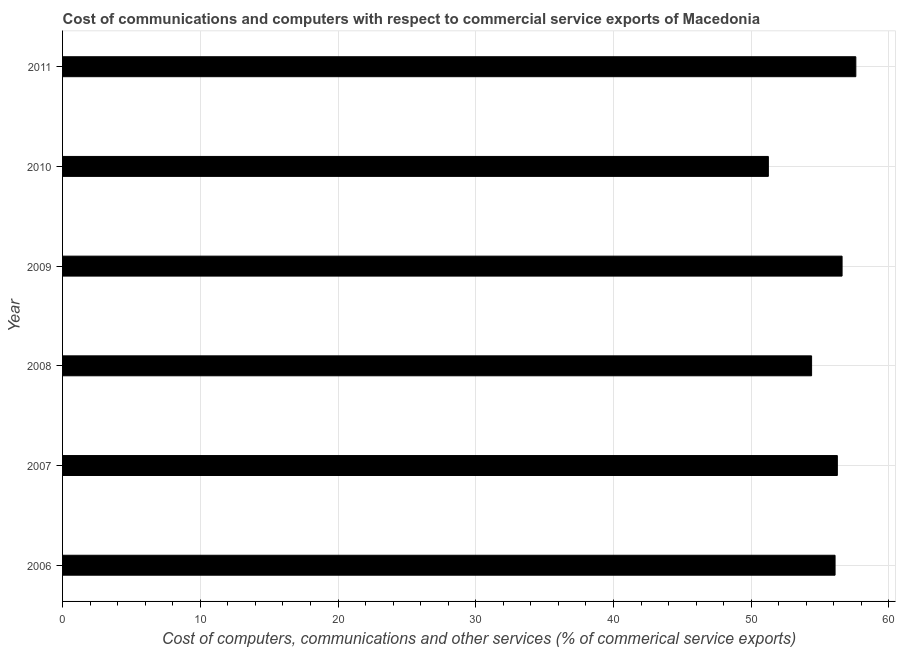What is the title of the graph?
Provide a short and direct response. Cost of communications and computers with respect to commercial service exports of Macedonia. What is the label or title of the X-axis?
Your answer should be compact. Cost of computers, communications and other services (% of commerical service exports). What is the label or title of the Y-axis?
Offer a very short reply. Year. What is the  computer and other services in 2010?
Provide a short and direct response. 51.24. Across all years, what is the maximum cost of communications?
Keep it short and to the point. 57.59. Across all years, what is the minimum cost of communications?
Offer a terse response. 51.24. In which year was the cost of communications minimum?
Offer a terse response. 2010. What is the sum of the cost of communications?
Keep it short and to the point. 332.15. What is the difference between the cost of communications in 2010 and 2011?
Provide a succinct answer. -6.35. What is the average cost of communications per year?
Make the answer very short. 55.36. What is the median cost of communications?
Your response must be concise. 56.17. Do a majority of the years between 2009 and 2006 (inclusive) have  computer and other services greater than 46 %?
Offer a very short reply. Yes. Is the difference between the  computer and other services in 2007 and 2011 greater than the difference between any two years?
Your response must be concise. No. Is the sum of the  computer and other services in 2008 and 2009 greater than the maximum  computer and other services across all years?
Your answer should be very brief. Yes. What is the difference between the highest and the lowest cost of communications?
Keep it short and to the point. 6.35. In how many years, is the cost of communications greater than the average cost of communications taken over all years?
Make the answer very short. 4. How many bars are there?
Your response must be concise. 6. Are all the bars in the graph horizontal?
Keep it short and to the point. Yes. How many years are there in the graph?
Make the answer very short. 6. What is the difference between two consecutive major ticks on the X-axis?
Your answer should be very brief. 10. Are the values on the major ticks of X-axis written in scientific E-notation?
Make the answer very short. No. What is the Cost of computers, communications and other services (% of commerical service exports) of 2006?
Offer a very short reply. 56.09. What is the Cost of computers, communications and other services (% of commerical service exports) in 2007?
Ensure brevity in your answer.  56.25. What is the Cost of computers, communications and other services (% of commerical service exports) in 2008?
Give a very brief answer. 54.38. What is the Cost of computers, communications and other services (% of commerical service exports) in 2009?
Offer a terse response. 56.6. What is the Cost of computers, communications and other services (% of commerical service exports) of 2010?
Give a very brief answer. 51.24. What is the Cost of computers, communications and other services (% of commerical service exports) of 2011?
Offer a terse response. 57.59. What is the difference between the Cost of computers, communications and other services (% of commerical service exports) in 2006 and 2007?
Provide a succinct answer. -0.17. What is the difference between the Cost of computers, communications and other services (% of commerical service exports) in 2006 and 2008?
Offer a terse response. 1.7. What is the difference between the Cost of computers, communications and other services (% of commerical service exports) in 2006 and 2009?
Keep it short and to the point. -0.51. What is the difference between the Cost of computers, communications and other services (% of commerical service exports) in 2006 and 2010?
Provide a short and direct response. 4.84. What is the difference between the Cost of computers, communications and other services (% of commerical service exports) in 2006 and 2011?
Keep it short and to the point. -1.51. What is the difference between the Cost of computers, communications and other services (% of commerical service exports) in 2007 and 2008?
Your answer should be compact. 1.87. What is the difference between the Cost of computers, communications and other services (% of commerical service exports) in 2007 and 2009?
Ensure brevity in your answer.  -0.34. What is the difference between the Cost of computers, communications and other services (% of commerical service exports) in 2007 and 2010?
Provide a short and direct response. 5.01. What is the difference between the Cost of computers, communications and other services (% of commerical service exports) in 2007 and 2011?
Your answer should be very brief. -1.34. What is the difference between the Cost of computers, communications and other services (% of commerical service exports) in 2008 and 2009?
Your answer should be compact. -2.21. What is the difference between the Cost of computers, communications and other services (% of commerical service exports) in 2008 and 2010?
Provide a short and direct response. 3.14. What is the difference between the Cost of computers, communications and other services (% of commerical service exports) in 2008 and 2011?
Keep it short and to the point. -3.21. What is the difference between the Cost of computers, communications and other services (% of commerical service exports) in 2009 and 2010?
Provide a succinct answer. 5.35. What is the difference between the Cost of computers, communications and other services (% of commerical service exports) in 2009 and 2011?
Your response must be concise. -1. What is the difference between the Cost of computers, communications and other services (% of commerical service exports) in 2010 and 2011?
Your response must be concise. -6.35. What is the ratio of the Cost of computers, communications and other services (% of commerical service exports) in 2006 to that in 2007?
Ensure brevity in your answer.  1. What is the ratio of the Cost of computers, communications and other services (% of commerical service exports) in 2006 to that in 2008?
Your response must be concise. 1.03. What is the ratio of the Cost of computers, communications and other services (% of commerical service exports) in 2006 to that in 2010?
Offer a terse response. 1.09. What is the ratio of the Cost of computers, communications and other services (% of commerical service exports) in 2006 to that in 2011?
Keep it short and to the point. 0.97. What is the ratio of the Cost of computers, communications and other services (% of commerical service exports) in 2007 to that in 2008?
Make the answer very short. 1.03. What is the ratio of the Cost of computers, communications and other services (% of commerical service exports) in 2007 to that in 2010?
Your answer should be very brief. 1.1. What is the ratio of the Cost of computers, communications and other services (% of commerical service exports) in 2008 to that in 2010?
Keep it short and to the point. 1.06. What is the ratio of the Cost of computers, communications and other services (% of commerical service exports) in 2008 to that in 2011?
Your answer should be very brief. 0.94. What is the ratio of the Cost of computers, communications and other services (% of commerical service exports) in 2009 to that in 2010?
Your answer should be very brief. 1.1. What is the ratio of the Cost of computers, communications and other services (% of commerical service exports) in 2010 to that in 2011?
Keep it short and to the point. 0.89. 